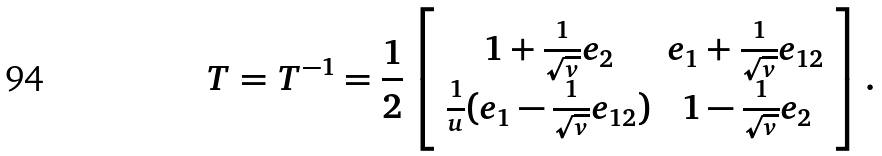Convert formula to latex. <formula><loc_0><loc_0><loc_500><loc_500>T = T ^ { - 1 } = \frac { 1 } { 2 } \left [ \begin{array} { c c } 1 + \frac { 1 } { \sqrt { v } } e _ { 2 } & e _ { 1 } + \frac { 1 } { \sqrt { v } } e _ { 1 2 } \\ \frac { 1 } { u } ( e _ { 1 } - \frac { 1 } { \sqrt { v } } e _ { 1 2 } ) & 1 - \frac { 1 } { \sqrt { v } } e _ { 2 } \end{array} \right ] .</formula> 